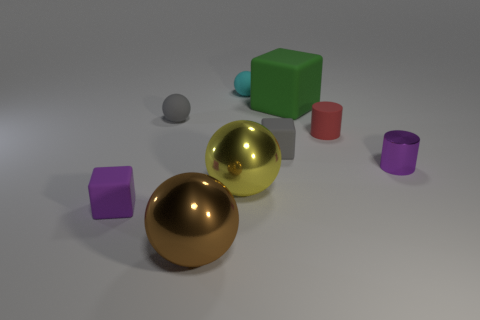Subtract 1 balls. How many balls are left? 3 Subtract all purple balls. Subtract all green cylinders. How many balls are left? 4 Add 1 small red cylinders. How many objects exist? 10 Subtract all spheres. How many objects are left? 5 Subtract all tiny rubber spheres. Subtract all small purple metal cylinders. How many objects are left? 6 Add 7 yellow metallic objects. How many yellow metallic objects are left? 8 Add 2 blue metallic things. How many blue metallic things exist? 2 Subtract 1 brown spheres. How many objects are left? 8 